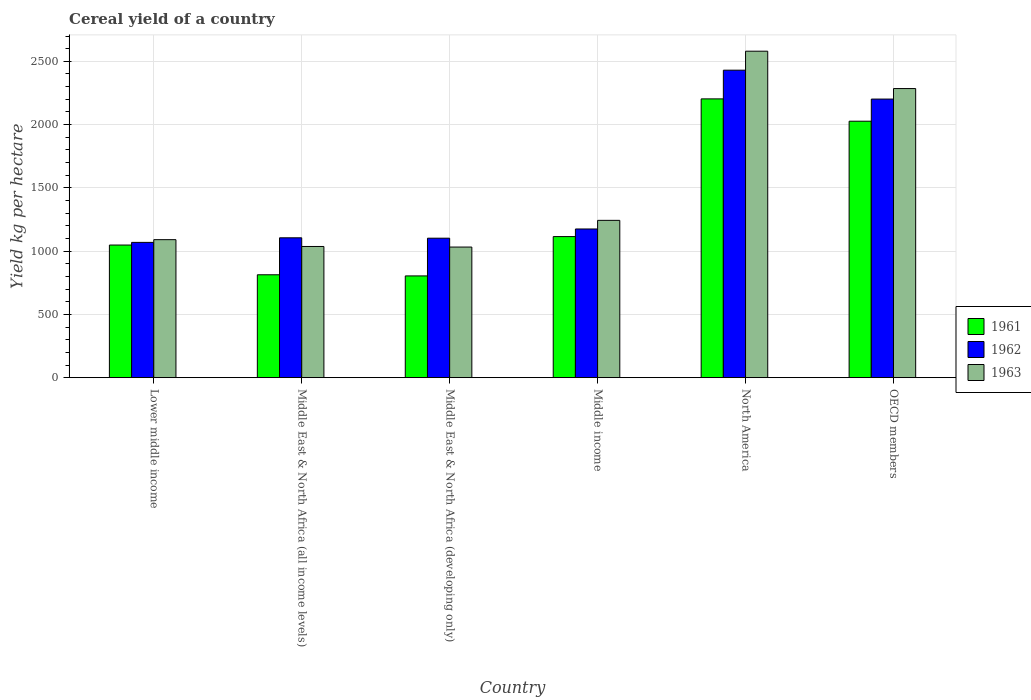Are the number of bars on each tick of the X-axis equal?
Your answer should be very brief. Yes. How many bars are there on the 2nd tick from the right?
Your answer should be compact. 3. What is the total cereal yield in 1962 in North America?
Provide a short and direct response. 2430.22. Across all countries, what is the maximum total cereal yield in 1961?
Offer a terse response. 2203.29. Across all countries, what is the minimum total cereal yield in 1963?
Provide a short and direct response. 1032.31. In which country was the total cereal yield in 1963 maximum?
Your response must be concise. North America. In which country was the total cereal yield in 1962 minimum?
Provide a succinct answer. Lower middle income. What is the total total cereal yield in 1961 in the graph?
Ensure brevity in your answer.  8010.66. What is the difference between the total cereal yield in 1962 in Middle East & North Africa (all income levels) and that in OECD members?
Offer a terse response. -1096.49. What is the difference between the total cereal yield in 1961 in OECD members and the total cereal yield in 1963 in Lower middle income?
Your response must be concise. 936.19. What is the average total cereal yield in 1962 per country?
Give a very brief answer. 1514. What is the difference between the total cereal yield of/in 1962 and total cereal yield of/in 1963 in North America?
Provide a short and direct response. -149.98. In how many countries, is the total cereal yield in 1962 greater than 2300 kg per hectare?
Provide a short and direct response. 1. What is the ratio of the total cereal yield in 1963 in North America to that in OECD members?
Provide a short and direct response. 1.13. Is the total cereal yield in 1961 in Middle East & North Africa (all income levels) less than that in OECD members?
Make the answer very short. Yes. What is the difference between the highest and the second highest total cereal yield in 1961?
Offer a very short reply. -176.41. What is the difference between the highest and the lowest total cereal yield in 1961?
Your answer should be compact. 1399.14. In how many countries, is the total cereal yield in 1962 greater than the average total cereal yield in 1962 taken over all countries?
Ensure brevity in your answer.  2. What does the 2nd bar from the right in OECD members represents?
Make the answer very short. 1962. How many bars are there?
Give a very brief answer. 18. Are all the bars in the graph horizontal?
Offer a very short reply. No. How many countries are there in the graph?
Give a very brief answer. 6. What is the difference between two consecutive major ticks on the Y-axis?
Your answer should be compact. 500. How many legend labels are there?
Provide a short and direct response. 3. How are the legend labels stacked?
Offer a very short reply. Vertical. What is the title of the graph?
Provide a short and direct response. Cereal yield of a country. What is the label or title of the X-axis?
Give a very brief answer. Country. What is the label or title of the Y-axis?
Offer a terse response. Yield kg per hectare. What is the Yield kg per hectare in 1961 in Lower middle income?
Make the answer very short. 1048.21. What is the Yield kg per hectare of 1962 in Lower middle income?
Give a very brief answer. 1069.15. What is the Yield kg per hectare in 1963 in Lower middle income?
Provide a succinct answer. 1090.7. What is the Yield kg per hectare in 1961 in Middle East & North Africa (all income levels)?
Provide a succinct answer. 813.16. What is the Yield kg per hectare of 1962 in Middle East & North Africa (all income levels)?
Your answer should be compact. 1105.39. What is the Yield kg per hectare in 1963 in Middle East & North Africa (all income levels)?
Your answer should be compact. 1036.88. What is the Yield kg per hectare in 1961 in Middle East & North Africa (developing only)?
Your response must be concise. 804.16. What is the Yield kg per hectare of 1962 in Middle East & North Africa (developing only)?
Ensure brevity in your answer.  1102.28. What is the Yield kg per hectare of 1963 in Middle East & North Africa (developing only)?
Provide a succinct answer. 1032.31. What is the Yield kg per hectare in 1961 in Middle income?
Your answer should be compact. 1114.95. What is the Yield kg per hectare of 1962 in Middle income?
Give a very brief answer. 1175.1. What is the Yield kg per hectare in 1963 in Middle income?
Provide a short and direct response. 1243.31. What is the Yield kg per hectare of 1961 in North America?
Provide a succinct answer. 2203.29. What is the Yield kg per hectare of 1962 in North America?
Provide a short and direct response. 2430.22. What is the Yield kg per hectare of 1963 in North America?
Offer a very short reply. 2580.19. What is the Yield kg per hectare of 1961 in OECD members?
Your answer should be very brief. 2026.89. What is the Yield kg per hectare in 1962 in OECD members?
Your response must be concise. 2201.88. What is the Yield kg per hectare of 1963 in OECD members?
Your response must be concise. 2284.91. Across all countries, what is the maximum Yield kg per hectare of 1961?
Your answer should be compact. 2203.29. Across all countries, what is the maximum Yield kg per hectare in 1962?
Ensure brevity in your answer.  2430.22. Across all countries, what is the maximum Yield kg per hectare in 1963?
Give a very brief answer. 2580.19. Across all countries, what is the minimum Yield kg per hectare of 1961?
Offer a terse response. 804.16. Across all countries, what is the minimum Yield kg per hectare of 1962?
Your answer should be very brief. 1069.15. Across all countries, what is the minimum Yield kg per hectare of 1963?
Your answer should be very brief. 1032.31. What is the total Yield kg per hectare in 1961 in the graph?
Give a very brief answer. 8010.66. What is the total Yield kg per hectare in 1962 in the graph?
Keep it short and to the point. 9084.01. What is the total Yield kg per hectare of 1963 in the graph?
Ensure brevity in your answer.  9268.31. What is the difference between the Yield kg per hectare in 1961 in Lower middle income and that in Middle East & North Africa (all income levels)?
Provide a succinct answer. 235.05. What is the difference between the Yield kg per hectare in 1962 in Lower middle income and that in Middle East & North Africa (all income levels)?
Your answer should be very brief. -36.24. What is the difference between the Yield kg per hectare of 1963 in Lower middle income and that in Middle East & North Africa (all income levels)?
Offer a very short reply. 53.82. What is the difference between the Yield kg per hectare in 1961 in Lower middle income and that in Middle East & North Africa (developing only)?
Make the answer very short. 244.06. What is the difference between the Yield kg per hectare in 1962 in Lower middle income and that in Middle East & North Africa (developing only)?
Provide a short and direct response. -33.13. What is the difference between the Yield kg per hectare of 1963 in Lower middle income and that in Middle East & North Africa (developing only)?
Provide a succinct answer. 58.39. What is the difference between the Yield kg per hectare in 1961 in Lower middle income and that in Middle income?
Your response must be concise. -66.73. What is the difference between the Yield kg per hectare of 1962 in Lower middle income and that in Middle income?
Your answer should be very brief. -105.95. What is the difference between the Yield kg per hectare in 1963 in Lower middle income and that in Middle income?
Make the answer very short. -152.61. What is the difference between the Yield kg per hectare in 1961 in Lower middle income and that in North America?
Keep it short and to the point. -1155.08. What is the difference between the Yield kg per hectare in 1962 in Lower middle income and that in North America?
Ensure brevity in your answer.  -1361.07. What is the difference between the Yield kg per hectare in 1963 in Lower middle income and that in North America?
Give a very brief answer. -1489.49. What is the difference between the Yield kg per hectare of 1961 in Lower middle income and that in OECD members?
Your answer should be compact. -978.67. What is the difference between the Yield kg per hectare in 1962 in Lower middle income and that in OECD members?
Give a very brief answer. -1132.73. What is the difference between the Yield kg per hectare in 1963 in Lower middle income and that in OECD members?
Offer a very short reply. -1194.21. What is the difference between the Yield kg per hectare of 1961 in Middle East & North Africa (all income levels) and that in Middle East & North Africa (developing only)?
Provide a succinct answer. 9. What is the difference between the Yield kg per hectare of 1962 in Middle East & North Africa (all income levels) and that in Middle East & North Africa (developing only)?
Provide a short and direct response. 3.11. What is the difference between the Yield kg per hectare of 1963 in Middle East & North Africa (all income levels) and that in Middle East & North Africa (developing only)?
Provide a short and direct response. 4.58. What is the difference between the Yield kg per hectare in 1961 in Middle East & North Africa (all income levels) and that in Middle income?
Keep it short and to the point. -301.78. What is the difference between the Yield kg per hectare in 1962 in Middle East & North Africa (all income levels) and that in Middle income?
Ensure brevity in your answer.  -69.71. What is the difference between the Yield kg per hectare of 1963 in Middle East & North Africa (all income levels) and that in Middle income?
Make the answer very short. -206.43. What is the difference between the Yield kg per hectare of 1961 in Middle East & North Africa (all income levels) and that in North America?
Make the answer very short. -1390.13. What is the difference between the Yield kg per hectare in 1962 in Middle East & North Africa (all income levels) and that in North America?
Your answer should be very brief. -1324.83. What is the difference between the Yield kg per hectare of 1963 in Middle East & North Africa (all income levels) and that in North America?
Your answer should be compact. -1543.31. What is the difference between the Yield kg per hectare in 1961 in Middle East & North Africa (all income levels) and that in OECD members?
Give a very brief answer. -1213.72. What is the difference between the Yield kg per hectare of 1962 in Middle East & North Africa (all income levels) and that in OECD members?
Give a very brief answer. -1096.49. What is the difference between the Yield kg per hectare of 1963 in Middle East & North Africa (all income levels) and that in OECD members?
Offer a terse response. -1248.03. What is the difference between the Yield kg per hectare in 1961 in Middle East & North Africa (developing only) and that in Middle income?
Make the answer very short. -310.79. What is the difference between the Yield kg per hectare in 1962 in Middle East & North Africa (developing only) and that in Middle income?
Your response must be concise. -72.82. What is the difference between the Yield kg per hectare in 1963 in Middle East & North Africa (developing only) and that in Middle income?
Your response must be concise. -211. What is the difference between the Yield kg per hectare in 1961 in Middle East & North Africa (developing only) and that in North America?
Offer a terse response. -1399.14. What is the difference between the Yield kg per hectare of 1962 in Middle East & North Africa (developing only) and that in North America?
Offer a terse response. -1327.94. What is the difference between the Yield kg per hectare of 1963 in Middle East & North Africa (developing only) and that in North America?
Your answer should be very brief. -1547.89. What is the difference between the Yield kg per hectare of 1961 in Middle East & North Africa (developing only) and that in OECD members?
Your answer should be very brief. -1222.73. What is the difference between the Yield kg per hectare of 1962 in Middle East & North Africa (developing only) and that in OECD members?
Ensure brevity in your answer.  -1099.6. What is the difference between the Yield kg per hectare of 1963 in Middle East & North Africa (developing only) and that in OECD members?
Offer a very short reply. -1252.61. What is the difference between the Yield kg per hectare in 1961 in Middle income and that in North America?
Keep it short and to the point. -1088.35. What is the difference between the Yield kg per hectare of 1962 in Middle income and that in North America?
Make the answer very short. -1255.12. What is the difference between the Yield kg per hectare of 1963 in Middle income and that in North America?
Give a very brief answer. -1336.88. What is the difference between the Yield kg per hectare in 1961 in Middle income and that in OECD members?
Offer a terse response. -911.94. What is the difference between the Yield kg per hectare of 1962 in Middle income and that in OECD members?
Your answer should be very brief. -1026.78. What is the difference between the Yield kg per hectare in 1963 in Middle income and that in OECD members?
Your answer should be very brief. -1041.6. What is the difference between the Yield kg per hectare of 1961 in North America and that in OECD members?
Make the answer very short. 176.41. What is the difference between the Yield kg per hectare in 1962 in North America and that in OECD members?
Ensure brevity in your answer.  228.34. What is the difference between the Yield kg per hectare of 1963 in North America and that in OECD members?
Ensure brevity in your answer.  295.28. What is the difference between the Yield kg per hectare in 1961 in Lower middle income and the Yield kg per hectare in 1962 in Middle East & North Africa (all income levels)?
Offer a terse response. -57.17. What is the difference between the Yield kg per hectare in 1961 in Lower middle income and the Yield kg per hectare in 1963 in Middle East & North Africa (all income levels)?
Offer a very short reply. 11.33. What is the difference between the Yield kg per hectare in 1962 in Lower middle income and the Yield kg per hectare in 1963 in Middle East & North Africa (all income levels)?
Provide a short and direct response. 32.26. What is the difference between the Yield kg per hectare of 1961 in Lower middle income and the Yield kg per hectare of 1962 in Middle East & North Africa (developing only)?
Provide a succinct answer. -54.07. What is the difference between the Yield kg per hectare in 1961 in Lower middle income and the Yield kg per hectare in 1963 in Middle East & North Africa (developing only)?
Keep it short and to the point. 15.9. What is the difference between the Yield kg per hectare in 1962 in Lower middle income and the Yield kg per hectare in 1963 in Middle East & North Africa (developing only)?
Your response must be concise. 36.84. What is the difference between the Yield kg per hectare in 1961 in Lower middle income and the Yield kg per hectare in 1962 in Middle income?
Your answer should be very brief. -126.89. What is the difference between the Yield kg per hectare of 1961 in Lower middle income and the Yield kg per hectare of 1963 in Middle income?
Your response must be concise. -195.1. What is the difference between the Yield kg per hectare in 1962 in Lower middle income and the Yield kg per hectare in 1963 in Middle income?
Ensure brevity in your answer.  -174.17. What is the difference between the Yield kg per hectare of 1961 in Lower middle income and the Yield kg per hectare of 1962 in North America?
Offer a terse response. -1382.01. What is the difference between the Yield kg per hectare of 1961 in Lower middle income and the Yield kg per hectare of 1963 in North America?
Ensure brevity in your answer.  -1531.98. What is the difference between the Yield kg per hectare in 1962 in Lower middle income and the Yield kg per hectare in 1963 in North America?
Make the answer very short. -1511.05. What is the difference between the Yield kg per hectare of 1961 in Lower middle income and the Yield kg per hectare of 1962 in OECD members?
Your answer should be very brief. -1153.67. What is the difference between the Yield kg per hectare in 1961 in Lower middle income and the Yield kg per hectare in 1963 in OECD members?
Your response must be concise. -1236.7. What is the difference between the Yield kg per hectare in 1962 in Lower middle income and the Yield kg per hectare in 1963 in OECD members?
Your response must be concise. -1215.77. What is the difference between the Yield kg per hectare in 1961 in Middle East & North Africa (all income levels) and the Yield kg per hectare in 1962 in Middle East & North Africa (developing only)?
Your response must be concise. -289.12. What is the difference between the Yield kg per hectare in 1961 in Middle East & North Africa (all income levels) and the Yield kg per hectare in 1963 in Middle East & North Africa (developing only)?
Provide a short and direct response. -219.15. What is the difference between the Yield kg per hectare of 1962 in Middle East & North Africa (all income levels) and the Yield kg per hectare of 1963 in Middle East & North Africa (developing only)?
Ensure brevity in your answer.  73.08. What is the difference between the Yield kg per hectare in 1961 in Middle East & North Africa (all income levels) and the Yield kg per hectare in 1962 in Middle income?
Make the answer very short. -361.94. What is the difference between the Yield kg per hectare in 1961 in Middle East & North Africa (all income levels) and the Yield kg per hectare in 1963 in Middle income?
Keep it short and to the point. -430.15. What is the difference between the Yield kg per hectare in 1962 in Middle East & North Africa (all income levels) and the Yield kg per hectare in 1963 in Middle income?
Make the answer very short. -137.92. What is the difference between the Yield kg per hectare in 1961 in Middle East & North Africa (all income levels) and the Yield kg per hectare in 1962 in North America?
Keep it short and to the point. -1617.06. What is the difference between the Yield kg per hectare in 1961 in Middle East & North Africa (all income levels) and the Yield kg per hectare in 1963 in North America?
Offer a terse response. -1767.03. What is the difference between the Yield kg per hectare of 1962 in Middle East & North Africa (all income levels) and the Yield kg per hectare of 1963 in North America?
Your answer should be compact. -1474.81. What is the difference between the Yield kg per hectare of 1961 in Middle East & North Africa (all income levels) and the Yield kg per hectare of 1962 in OECD members?
Your answer should be very brief. -1388.72. What is the difference between the Yield kg per hectare in 1961 in Middle East & North Africa (all income levels) and the Yield kg per hectare in 1963 in OECD members?
Make the answer very short. -1471.75. What is the difference between the Yield kg per hectare in 1962 in Middle East & North Africa (all income levels) and the Yield kg per hectare in 1963 in OECD members?
Provide a short and direct response. -1179.53. What is the difference between the Yield kg per hectare in 1961 in Middle East & North Africa (developing only) and the Yield kg per hectare in 1962 in Middle income?
Provide a short and direct response. -370.94. What is the difference between the Yield kg per hectare in 1961 in Middle East & North Africa (developing only) and the Yield kg per hectare in 1963 in Middle income?
Your answer should be compact. -439.15. What is the difference between the Yield kg per hectare in 1962 in Middle East & North Africa (developing only) and the Yield kg per hectare in 1963 in Middle income?
Give a very brief answer. -141.03. What is the difference between the Yield kg per hectare of 1961 in Middle East & North Africa (developing only) and the Yield kg per hectare of 1962 in North America?
Provide a succinct answer. -1626.06. What is the difference between the Yield kg per hectare of 1961 in Middle East & North Africa (developing only) and the Yield kg per hectare of 1963 in North America?
Provide a short and direct response. -1776.04. What is the difference between the Yield kg per hectare in 1962 in Middle East & North Africa (developing only) and the Yield kg per hectare in 1963 in North America?
Your response must be concise. -1477.91. What is the difference between the Yield kg per hectare in 1961 in Middle East & North Africa (developing only) and the Yield kg per hectare in 1962 in OECD members?
Ensure brevity in your answer.  -1397.72. What is the difference between the Yield kg per hectare in 1961 in Middle East & North Africa (developing only) and the Yield kg per hectare in 1963 in OECD members?
Keep it short and to the point. -1480.76. What is the difference between the Yield kg per hectare in 1962 in Middle East & North Africa (developing only) and the Yield kg per hectare in 1963 in OECD members?
Make the answer very short. -1182.63. What is the difference between the Yield kg per hectare of 1961 in Middle income and the Yield kg per hectare of 1962 in North America?
Make the answer very short. -1315.27. What is the difference between the Yield kg per hectare of 1961 in Middle income and the Yield kg per hectare of 1963 in North America?
Your answer should be very brief. -1465.25. What is the difference between the Yield kg per hectare in 1962 in Middle income and the Yield kg per hectare in 1963 in North America?
Provide a succinct answer. -1405.09. What is the difference between the Yield kg per hectare in 1961 in Middle income and the Yield kg per hectare in 1962 in OECD members?
Your answer should be compact. -1086.93. What is the difference between the Yield kg per hectare in 1961 in Middle income and the Yield kg per hectare in 1963 in OECD members?
Make the answer very short. -1169.97. What is the difference between the Yield kg per hectare in 1962 in Middle income and the Yield kg per hectare in 1963 in OECD members?
Provide a succinct answer. -1109.81. What is the difference between the Yield kg per hectare of 1961 in North America and the Yield kg per hectare of 1962 in OECD members?
Your answer should be very brief. 1.41. What is the difference between the Yield kg per hectare of 1961 in North America and the Yield kg per hectare of 1963 in OECD members?
Make the answer very short. -81.62. What is the difference between the Yield kg per hectare in 1962 in North America and the Yield kg per hectare in 1963 in OECD members?
Offer a very short reply. 145.3. What is the average Yield kg per hectare in 1961 per country?
Ensure brevity in your answer.  1335.11. What is the average Yield kg per hectare in 1962 per country?
Make the answer very short. 1514. What is the average Yield kg per hectare of 1963 per country?
Provide a succinct answer. 1544.72. What is the difference between the Yield kg per hectare of 1961 and Yield kg per hectare of 1962 in Lower middle income?
Your answer should be compact. -20.93. What is the difference between the Yield kg per hectare in 1961 and Yield kg per hectare in 1963 in Lower middle income?
Make the answer very short. -42.49. What is the difference between the Yield kg per hectare in 1962 and Yield kg per hectare in 1963 in Lower middle income?
Provide a succinct answer. -21.55. What is the difference between the Yield kg per hectare in 1961 and Yield kg per hectare in 1962 in Middle East & North Africa (all income levels)?
Ensure brevity in your answer.  -292.23. What is the difference between the Yield kg per hectare in 1961 and Yield kg per hectare in 1963 in Middle East & North Africa (all income levels)?
Give a very brief answer. -223.72. What is the difference between the Yield kg per hectare in 1962 and Yield kg per hectare in 1963 in Middle East & North Africa (all income levels)?
Give a very brief answer. 68.5. What is the difference between the Yield kg per hectare of 1961 and Yield kg per hectare of 1962 in Middle East & North Africa (developing only)?
Give a very brief answer. -298.12. What is the difference between the Yield kg per hectare of 1961 and Yield kg per hectare of 1963 in Middle East & North Africa (developing only)?
Make the answer very short. -228.15. What is the difference between the Yield kg per hectare in 1962 and Yield kg per hectare in 1963 in Middle East & North Africa (developing only)?
Make the answer very short. 69.97. What is the difference between the Yield kg per hectare of 1961 and Yield kg per hectare of 1962 in Middle income?
Provide a short and direct response. -60.15. What is the difference between the Yield kg per hectare in 1961 and Yield kg per hectare in 1963 in Middle income?
Ensure brevity in your answer.  -128.37. What is the difference between the Yield kg per hectare in 1962 and Yield kg per hectare in 1963 in Middle income?
Your answer should be compact. -68.21. What is the difference between the Yield kg per hectare in 1961 and Yield kg per hectare in 1962 in North America?
Make the answer very short. -226.92. What is the difference between the Yield kg per hectare in 1961 and Yield kg per hectare in 1963 in North America?
Offer a terse response. -376.9. What is the difference between the Yield kg per hectare of 1962 and Yield kg per hectare of 1963 in North America?
Keep it short and to the point. -149.98. What is the difference between the Yield kg per hectare in 1961 and Yield kg per hectare in 1962 in OECD members?
Ensure brevity in your answer.  -174.99. What is the difference between the Yield kg per hectare of 1961 and Yield kg per hectare of 1963 in OECD members?
Provide a short and direct response. -258.03. What is the difference between the Yield kg per hectare of 1962 and Yield kg per hectare of 1963 in OECD members?
Give a very brief answer. -83.03. What is the ratio of the Yield kg per hectare of 1961 in Lower middle income to that in Middle East & North Africa (all income levels)?
Make the answer very short. 1.29. What is the ratio of the Yield kg per hectare in 1962 in Lower middle income to that in Middle East & North Africa (all income levels)?
Provide a succinct answer. 0.97. What is the ratio of the Yield kg per hectare in 1963 in Lower middle income to that in Middle East & North Africa (all income levels)?
Your answer should be very brief. 1.05. What is the ratio of the Yield kg per hectare of 1961 in Lower middle income to that in Middle East & North Africa (developing only)?
Give a very brief answer. 1.3. What is the ratio of the Yield kg per hectare in 1962 in Lower middle income to that in Middle East & North Africa (developing only)?
Your answer should be compact. 0.97. What is the ratio of the Yield kg per hectare in 1963 in Lower middle income to that in Middle East & North Africa (developing only)?
Your answer should be compact. 1.06. What is the ratio of the Yield kg per hectare of 1961 in Lower middle income to that in Middle income?
Your answer should be compact. 0.94. What is the ratio of the Yield kg per hectare of 1962 in Lower middle income to that in Middle income?
Your response must be concise. 0.91. What is the ratio of the Yield kg per hectare in 1963 in Lower middle income to that in Middle income?
Ensure brevity in your answer.  0.88. What is the ratio of the Yield kg per hectare of 1961 in Lower middle income to that in North America?
Make the answer very short. 0.48. What is the ratio of the Yield kg per hectare in 1962 in Lower middle income to that in North America?
Provide a succinct answer. 0.44. What is the ratio of the Yield kg per hectare of 1963 in Lower middle income to that in North America?
Your answer should be very brief. 0.42. What is the ratio of the Yield kg per hectare in 1961 in Lower middle income to that in OECD members?
Offer a very short reply. 0.52. What is the ratio of the Yield kg per hectare of 1962 in Lower middle income to that in OECD members?
Provide a succinct answer. 0.49. What is the ratio of the Yield kg per hectare in 1963 in Lower middle income to that in OECD members?
Give a very brief answer. 0.48. What is the ratio of the Yield kg per hectare in 1961 in Middle East & North Africa (all income levels) to that in Middle East & North Africa (developing only)?
Your answer should be compact. 1.01. What is the ratio of the Yield kg per hectare of 1962 in Middle East & North Africa (all income levels) to that in Middle East & North Africa (developing only)?
Your response must be concise. 1. What is the ratio of the Yield kg per hectare of 1961 in Middle East & North Africa (all income levels) to that in Middle income?
Offer a very short reply. 0.73. What is the ratio of the Yield kg per hectare in 1962 in Middle East & North Africa (all income levels) to that in Middle income?
Provide a short and direct response. 0.94. What is the ratio of the Yield kg per hectare of 1963 in Middle East & North Africa (all income levels) to that in Middle income?
Offer a terse response. 0.83. What is the ratio of the Yield kg per hectare of 1961 in Middle East & North Africa (all income levels) to that in North America?
Keep it short and to the point. 0.37. What is the ratio of the Yield kg per hectare of 1962 in Middle East & North Africa (all income levels) to that in North America?
Provide a short and direct response. 0.45. What is the ratio of the Yield kg per hectare in 1963 in Middle East & North Africa (all income levels) to that in North America?
Ensure brevity in your answer.  0.4. What is the ratio of the Yield kg per hectare in 1961 in Middle East & North Africa (all income levels) to that in OECD members?
Give a very brief answer. 0.4. What is the ratio of the Yield kg per hectare of 1962 in Middle East & North Africa (all income levels) to that in OECD members?
Your answer should be very brief. 0.5. What is the ratio of the Yield kg per hectare in 1963 in Middle East & North Africa (all income levels) to that in OECD members?
Offer a very short reply. 0.45. What is the ratio of the Yield kg per hectare in 1961 in Middle East & North Africa (developing only) to that in Middle income?
Your answer should be compact. 0.72. What is the ratio of the Yield kg per hectare in 1962 in Middle East & North Africa (developing only) to that in Middle income?
Your answer should be compact. 0.94. What is the ratio of the Yield kg per hectare in 1963 in Middle East & North Africa (developing only) to that in Middle income?
Your answer should be very brief. 0.83. What is the ratio of the Yield kg per hectare in 1961 in Middle East & North Africa (developing only) to that in North America?
Make the answer very short. 0.36. What is the ratio of the Yield kg per hectare in 1962 in Middle East & North Africa (developing only) to that in North America?
Your answer should be compact. 0.45. What is the ratio of the Yield kg per hectare of 1963 in Middle East & North Africa (developing only) to that in North America?
Offer a very short reply. 0.4. What is the ratio of the Yield kg per hectare of 1961 in Middle East & North Africa (developing only) to that in OECD members?
Give a very brief answer. 0.4. What is the ratio of the Yield kg per hectare of 1962 in Middle East & North Africa (developing only) to that in OECD members?
Keep it short and to the point. 0.5. What is the ratio of the Yield kg per hectare of 1963 in Middle East & North Africa (developing only) to that in OECD members?
Your response must be concise. 0.45. What is the ratio of the Yield kg per hectare of 1961 in Middle income to that in North America?
Provide a short and direct response. 0.51. What is the ratio of the Yield kg per hectare of 1962 in Middle income to that in North America?
Give a very brief answer. 0.48. What is the ratio of the Yield kg per hectare of 1963 in Middle income to that in North America?
Make the answer very short. 0.48. What is the ratio of the Yield kg per hectare of 1961 in Middle income to that in OECD members?
Offer a very short reply. 0.55. What is the ratio of the Yield kg per hectare in 1962 in Middle income to that in OECD members?
Your answer should be very brief. 0.53. What is the ratio of the Yield kg per hectare in 1963 in Middle income to that in OECD members?
Your answer should be very brief. 0.54. What is the ratio of the Yield kg per hectare in 1961 in North America to that in OECD members?
Provide a short and direct response. 1.09. What is the ratio of the Yield kg per hectare of 1962 in North America to that in OECD members?
Make the answer very short. 1.1. What is the ratio of the Yield kg per hectare in 1963 in North America to that in OECD members?
Your response must be concise. 1.13. What is the difference between the highest and the second highest Yield kg per hectare of 1961?
Make the answer very short. 176.41. What is the difference between the highest and the second highest Yield kg per hectare in 1962?
Your answer should be compact. 228.34. What is the difference between the highest and the second highest Yield kg per hectare in 1963?
Offer a very short reply. 295.28. What is the difference between the highest and the lowest Yield kg per hectare in 1961?
Keep it short and to the point. 1399.14. What is the difference between the highest and the lowest Yield kg per hectare of 1962?
Your answer should be compact. 1361.07. What is the difference between the highest and the lowest Yield kg per hectare of 1963?
Offer a terse response. 1547.89. 